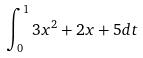<formula> <loc_0><loc_0><loc_500><loc_500>\int _ { 0 } ^ { 1 } 3 x ^ { 2 } + 2 x + 5 d t</formula> 